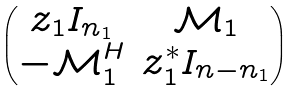Convert formula to latex. <formula><loc_0><loc_0><loc_500><loc_500>\begin{pmatrix} z _ { 1 } I _ { n _ { 1 } } & \mathcal { M } _ { 1 } \\ - \mathcal { M } ^ { H } _ { 1 } & z ^ { * } _ { 1 } I _ { n - n _ { 1 } } \end{pmatrix}</formula> 